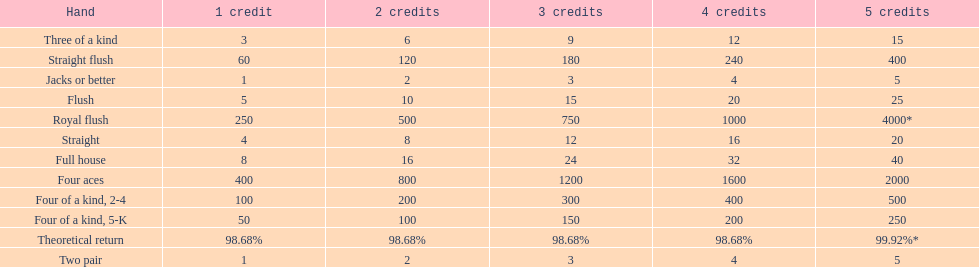What is the difference of payout on 3 credits, between a straight flush and royal flush? 570. 